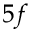Convert formula to latex. <formula><loc_0><loc_0><loc_500><loc_500>5 f</formula> 